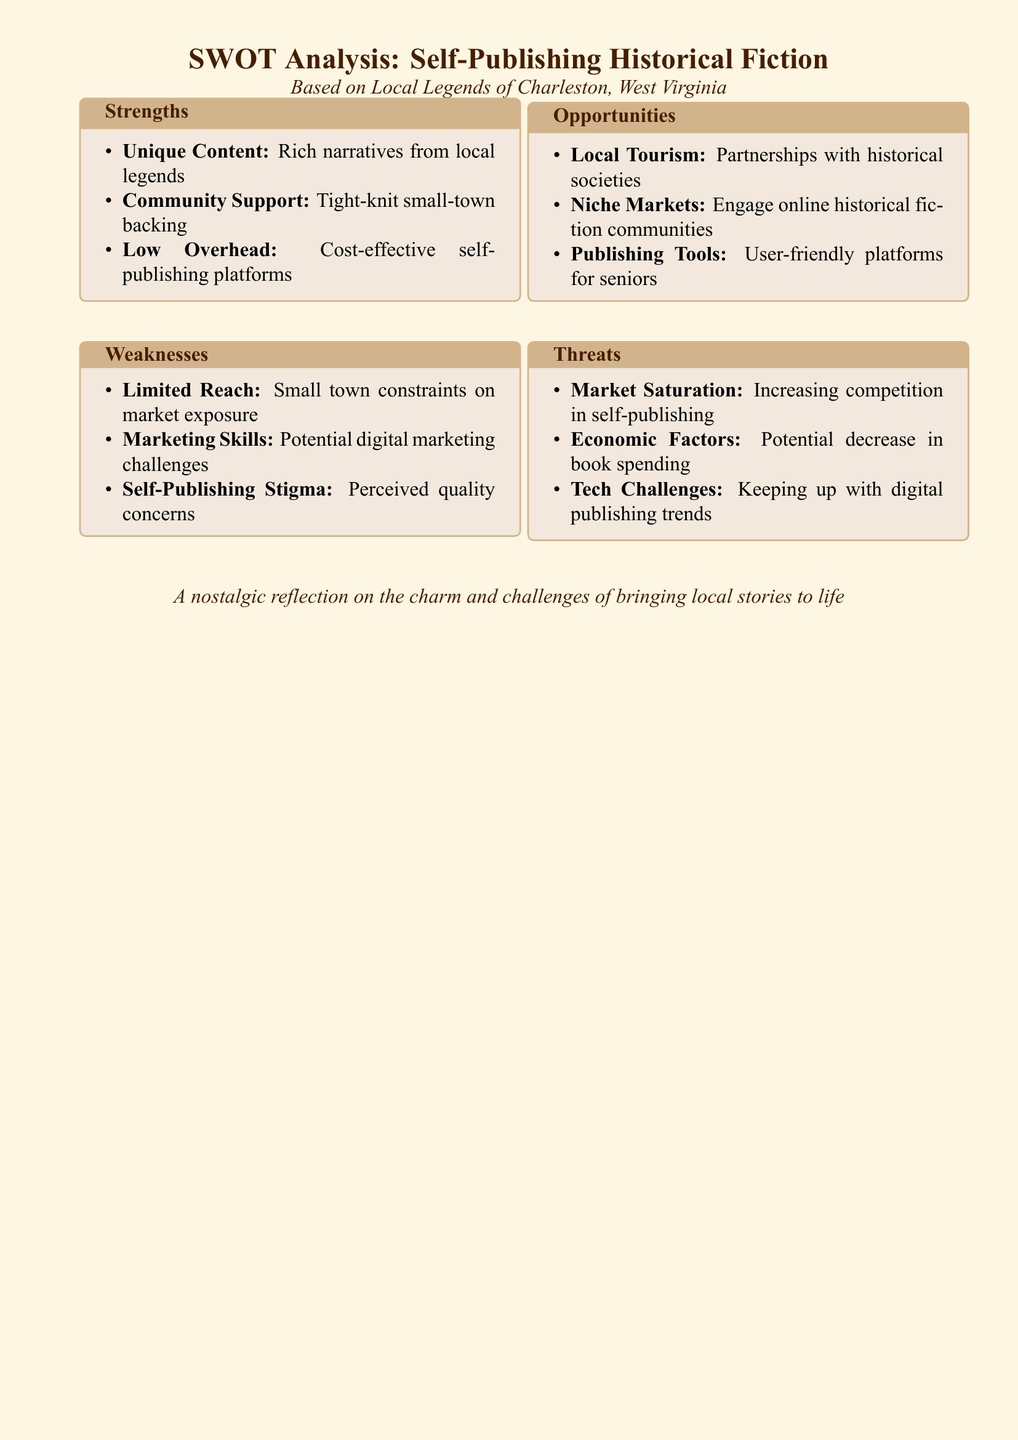What are the strengths listed? The strengths are detailed in the SWOT analysis section specifically addressing unique content, community support, and low overhead.
Answer: Unique Content, Community Support, Low Overhead What is one weakness mentioned? The weaknesses focus on issues affecting self-publishing, particularly limited reach and marketing challenges.
Answer: Limited Reach Which local legend-based opportunity is noted? Opportunities pertain to local tourism and potential partnerships that could enhance visibility for self-publishing efforts.
Answer: Local Tourism What threat relates to the market? The threats identified include factors that could impact self-publishing viability, one of which concerns market competition.
Answer: Market Saturation What is the primary document type? The document presents a specific analytical framework assessing potential ventures, indicative of a strategic assessment format.
Answer: SWOT Analysis How many strengths are listed in total? The total number of strengths is provided within the SWOT analysis section, showcasing three distinct areas of advantage.
Answer: 3 What type of content is emphasized for potential publishing? The content focus is on the local legends that can serve as the basis for creative writing and story development.
Answer: Historical Fiction Stories Which software tool user-friendliness aspect is highlighted? The opportunities section discusses the accessibility of certain publishing platforms, describing them as supportive for a specific demographic.
Answer: User-friendly platforms for seniors 